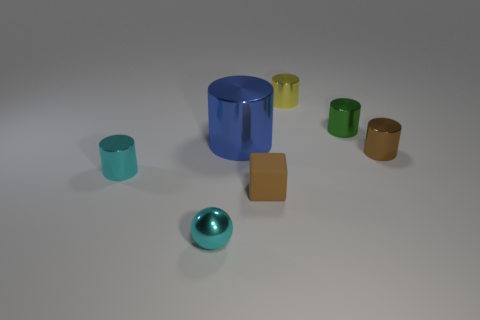What is the shape of the small thing that is the same color as the ball?
Provide a short and direct response. Cylinder. How many matte objects are big blue cubes or cyan balls?
Your answer should be very brief. 0. Does the rubber cube have the same color as the tiny metal ball?
Offer a very short reply. No. Are there any other things that have the same material as the brown cylinder?
Your answer should be compact. Yes. How many things are either blue things or tiny metal cylinders that are behind the big cylinder?
Your answer should be compact. 3. Does the cylinder that is to the left of the blue shiny cylinder have the same size as the large blue cylinder?
Offer a very short reply. No. How many other objects are there of the same shape as the green metal thing?
Ensure brevity in your answer.  4. How many green objects are balls or big shiny things?
Offer a terse response. 0. Is the color of the small cylinder left of the tiny rubber block the same as the small block?
Provide a short and direct response. No. There is a small yellow thing that is the same material as the large blue object; what shape is it?
Provide a succinct answer. Cylinder. 